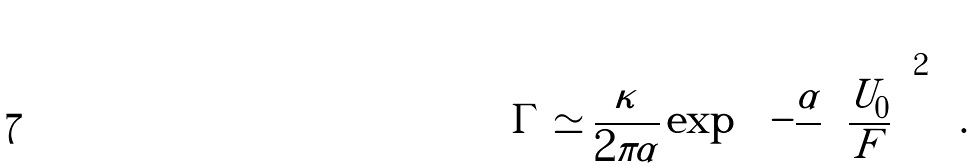Convert formula to latex. <formula><loc_0><loc_0><loc_500><loc_500>\Gamma \simeq \frac { \kappa } { 2 \pi \alpha } \exp { \left [ - \frac { \alpha } { } { \left ( \frac { U _ { 0 } } { F } \right ) } ^ { 2 } \right ] } .</formula> 